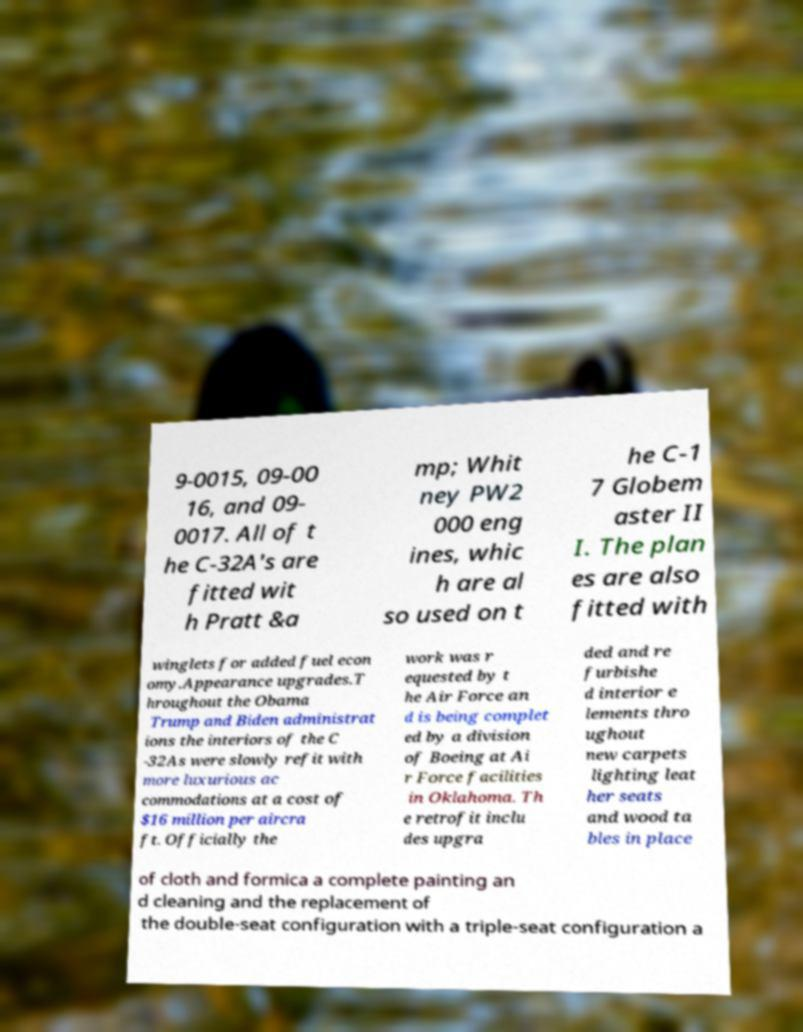Please read and relay the text visible in this image. What does it say? 9-0015, 09-00 16, and 09- 0017. All of t he C-32A's are fitted wit h Pratt &a mp; Whit ney PW2 000 eng ines, whic h are al so used on t he C-1 7 Globem aster II I. The plan es are also fitted with winglets for added fuel econ omy.Appearance upgrades.T hroughout the Obama Trump and Biden administrat ions the interiors of the C -32As were slowly refit with more luxurious ac commodations at a cost of $16 million per aircra ft. Officially the work was r equested by t he Air Force an d is being complet ed by a division of Boeing at Ai r Force facilities in Oklahoma. Th e retrofit inclu des upgra ded and re furbishe d interior e lements thro ughout new carpets lighting leat her seats and wood ta bles in place of cloth and formica a complete painting an d cleaning and the replacement of the double-seat configuration with a triple-seat configuration a 